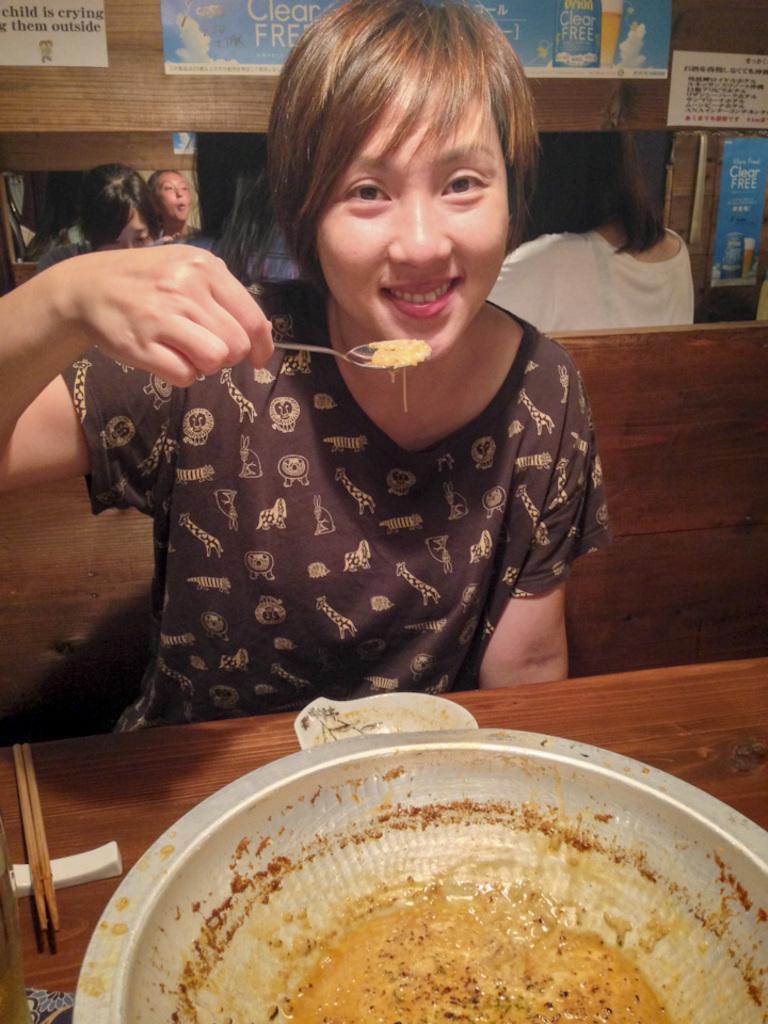Could you give a brief overview of what you see in this image? Woman in brown t-shirt is holding spoon in her hands and she is smiling. She is sitting on bench. In front of her, we see a brown table on which a bowl containing food is placed on it. Behind her, we see many people sitting and having their food. On top of the picture, we see many charts placed on the cupboard. 